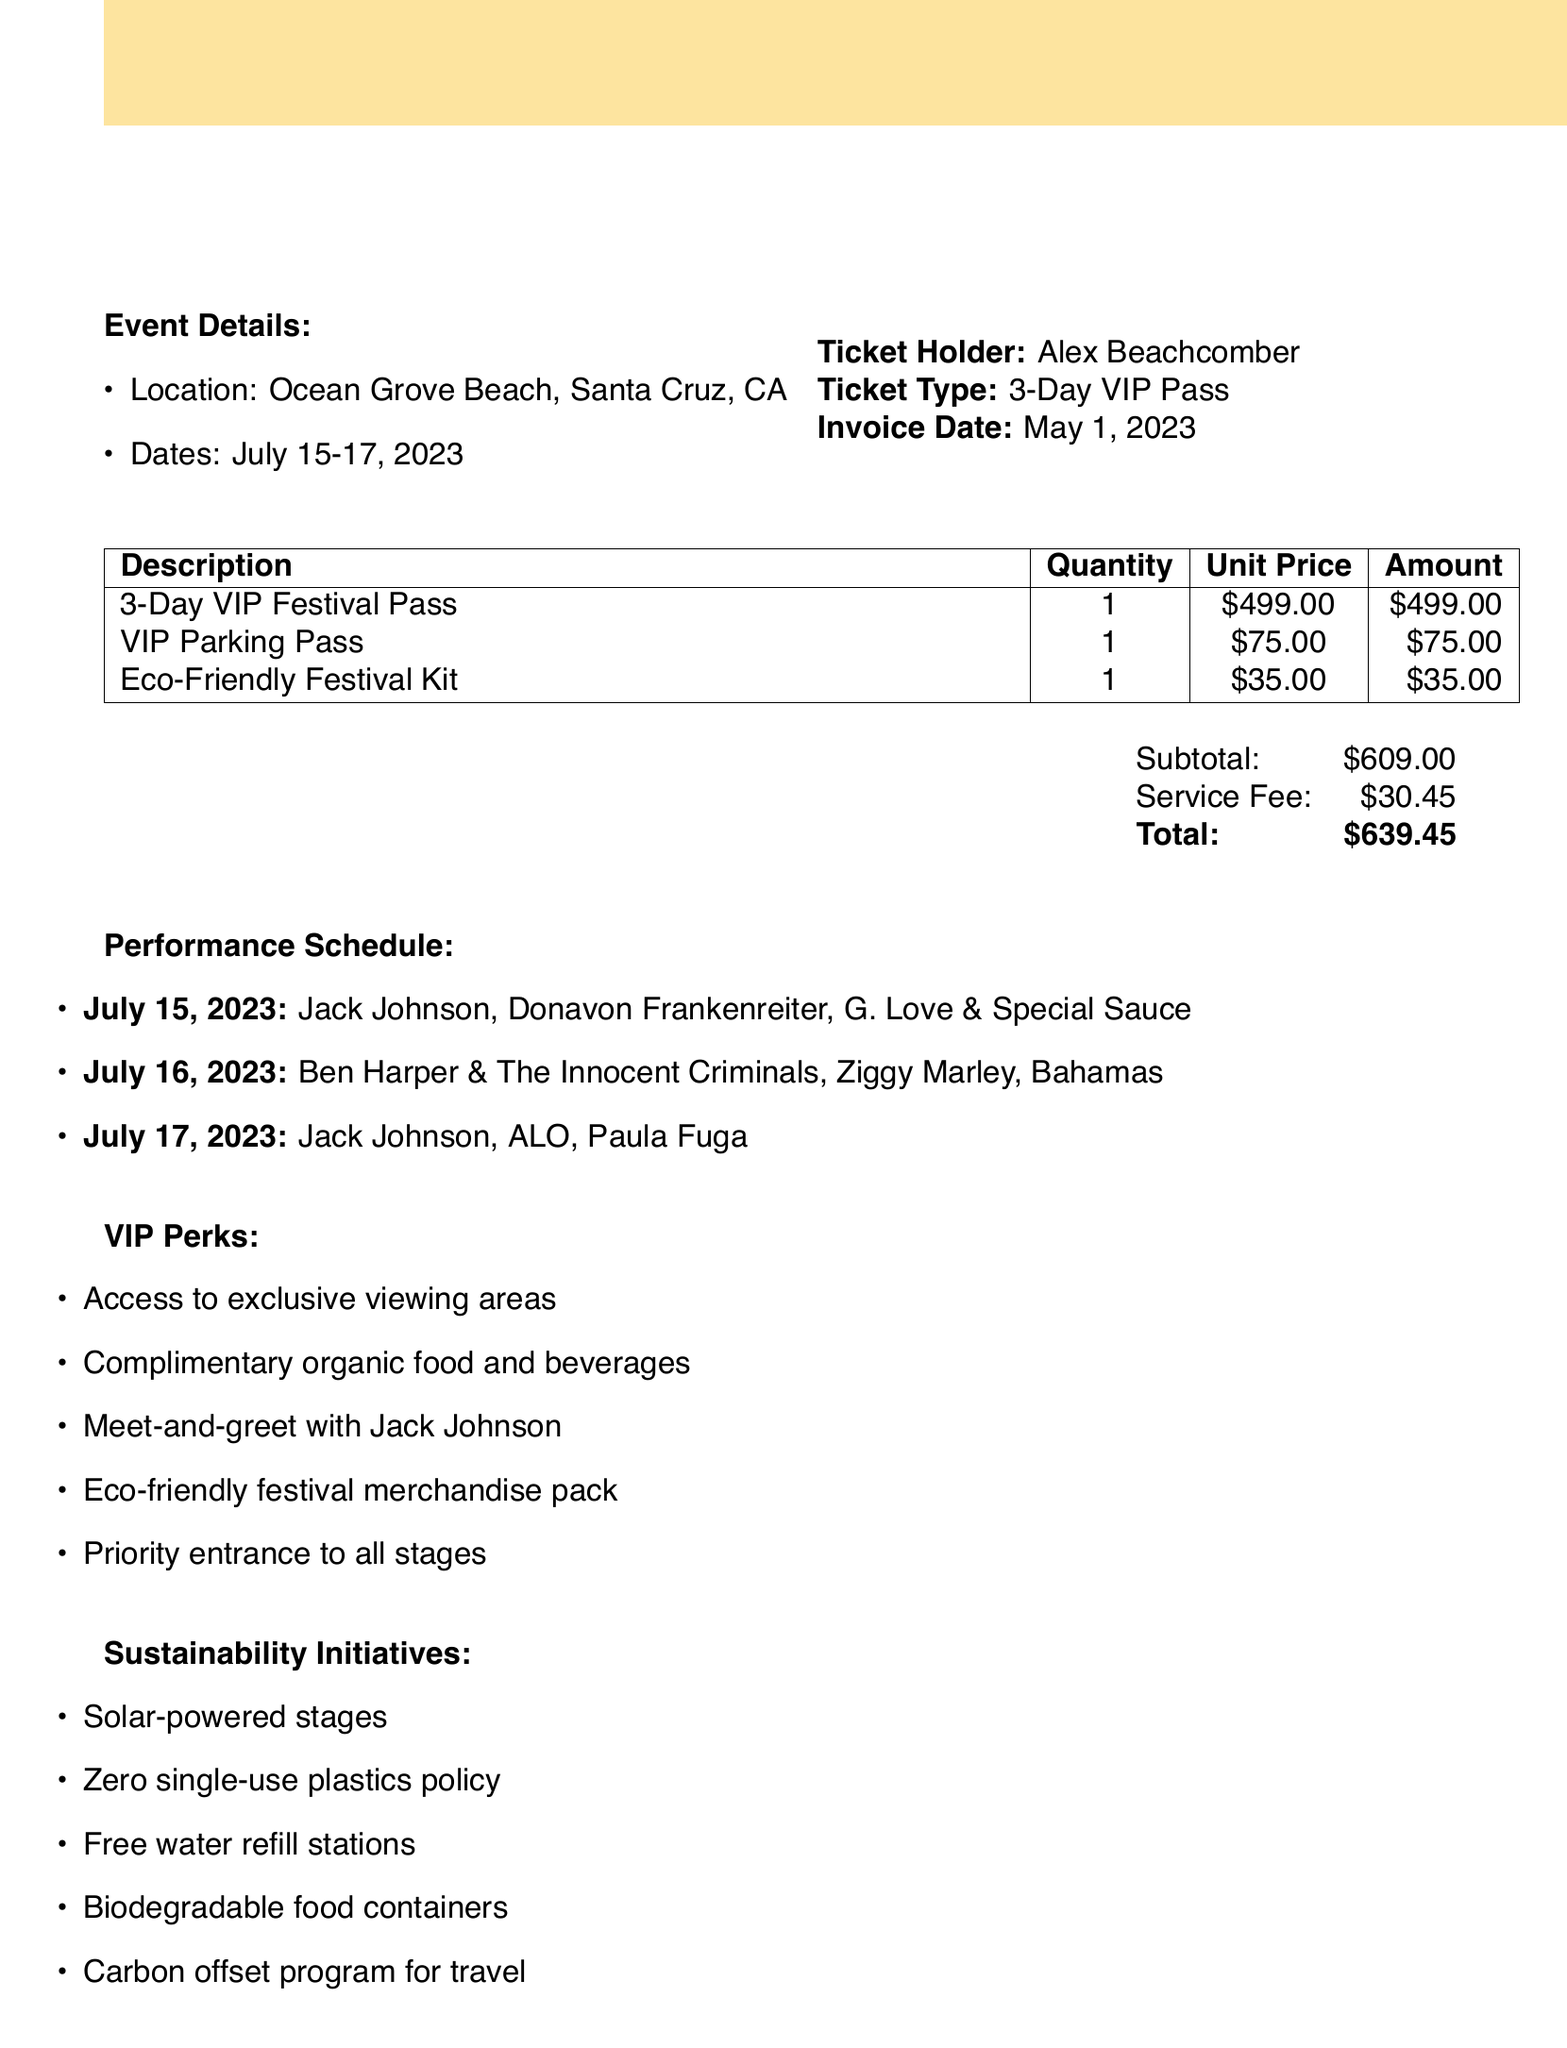What is the event name? The event name is stated at the top of the document and is "Sunburst Music Festival."
Answer: Sunburst Music Festival Who is the ticket holder? The ticket holder's name is provided in the document.
Answer: Alex Beachcomber What is the total amount due? The total amount is summarized at the end of the invoice.
Answer: $639.45 What dates does the festival take place? The dates of the festival are listed in the event details.
Answer: July 15-17, 2023 Which headliner performs on July 17, 2023? The headliner for July 17 is mentioned in the performance schedule.
Answer: Jack Johnson How much is the VIP Parking Pass? The unit price for the VIP Parking Pass is detailed in the line items.
Answer: $75.00 What is one of the VIP perks mentioned? The document lists several perks for VIP ticket holders; one can be mentioned.
Answer: Meet-and-greet with Jack Johnson What is the refund policy for the event? The refund policy is explicitly stated in the document.
Answer: No refunds. Event is rain or shine What type of ticket did Alex purchase? The type of ticket is clearly identified in the details.
Answer: 3-Day VIP Pass 